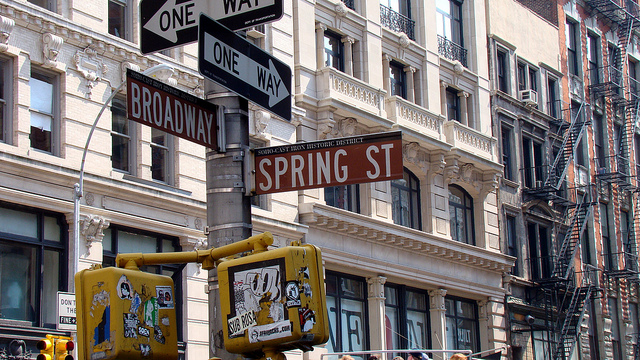Please identify all text content in this image. SPRING ST BROADWAY ONE WAY WAY ONE 